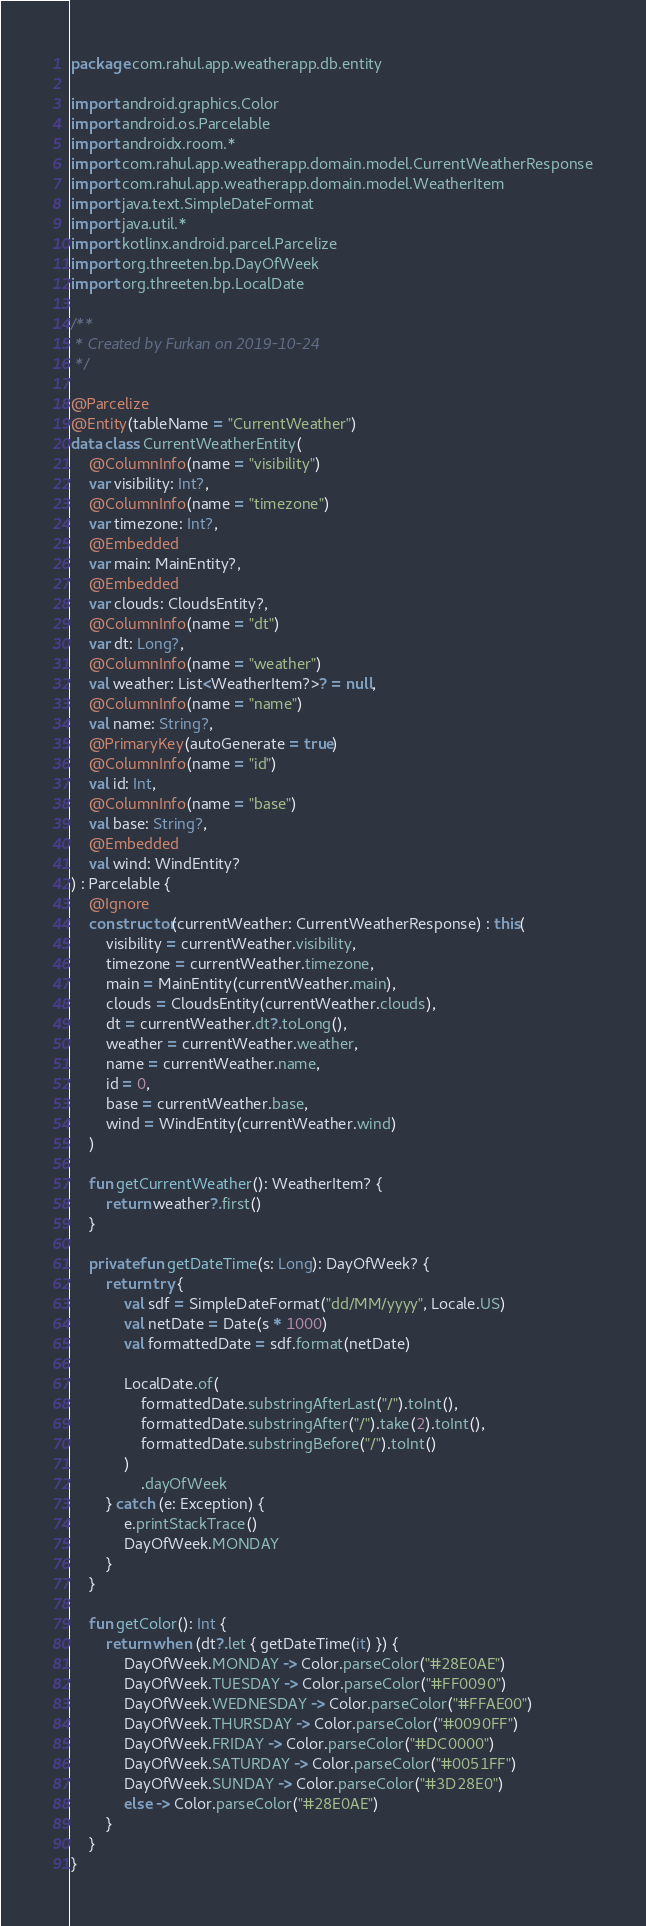Convert code to text. <code><loc_0><loc_0><loc_500><loc_500><_Kotlin_>package com.rahul.app.weatherapp.db.entity

import android.graphics.Color
import android.os.Parcelable
import androidx.room.*
import com.rahul.app.weatherapp.domain.model.CurrentWeatherResponse
import com.rahul.app.weatherapp.domain.model.WeatherItem
import java.text.SimpleDateFormat
import java.util.*
import kotlinx.android.parcel.Parcelize
import org.threeten.bp.DayOfWeek
import org.threeten.bp.LocalDate

/**
 * Created by Furkan on 2019-10-24
 */

@Parcelize
@Entity(tableName = "CurrentWeather")
data class CurrentWeatherEntity(
    @ColumnInfo(name = "visibility")
    var visibility: Int?,
    @ColumnInfo(name = "timezone")
    var timezone: Int?,
    @Embedded
    var main: MainEntity?,
    @Embedded
    var clouds: CloudsEntity?,
    @ColumnInfo(name = "dt")
    var dt: Long?,
    @ColumnInfo(name = "weather")
    val weather: List<WeatherItem?>? = null,
    @ColumnInfo(name = "name")
    val name: String?,
    @PrimaryKey(autoGenerate = true)
    @ColumnInfo(name = "id")
    val id: Int,
    @ColumnInfo(name = "base")
    val base: String?,
    @Embedded
    val wind: WindEntity?
) : Parcelable {
    @Ignore
    constructor(currentWeather: CurrentWeatherResponse) : this(
        visibility = currentWeather.visibility,
        timezone = currentWeather.timezone,
        main = MainEntity(currentWeather.main),
        clouds = CloudsEntity(currentWeather.clouds),
        dt = currentWeather.dt?.toLong(),
        weather = currentWeather.weather,
        name = currentWeather.name,
        id = 0,
        base = currentWeather.base,
        wind = WindEntity(currentWeather.wind)
    )

    fun getCurrentWeather(): WeatherItem? {
        return weather?.first()
    }

    private fun getDateTime(s: Long): DayOfWeek? {
        return try {
            val sdf = SimpleDateFormat("dd/MM/yyyy", Locale.US)
            val netDate = Date(s * 1000)
            val formattedDate = sdf.format(netDate)

            LocalDate.of(
                formattedDate.substringAfterLast("/").toInt(),
                formattedDate.substringAfter("/").take(2).toInt(),
                formattedDate.substringBefore("/").toInt()
            )
                .dayOfWeek
        } catch (e: Exception) {
            e.printStackTrace()
            DayOfWeek.MONDAY
        }
    }

    fun getColor(): Int {
        return when (dt?.let { getDateTime(it) }) {
            DayOfWeek.MONDAY -> Color.parseColor("#28E0AE")
            DayOfWeek.TUESDAY -> Color.parseColor("#FF0090")
            DayOfWeek.WEDNESDAY -> Color.parseColor("#FFAE00")
            DayOfWeek.THURSDAY -> Color.parseColor("#0090FF")
            DayOfWeek.FRIDAY -> Color.parseColor("#DC0000")
            DayOfWeek.SATURDAY -> Color.parseColor("#0051FF")
            DayOfWeek.SUNDAY -> Color.parseColor("#3D28E0")
            else -> Color.parseColor("#28E0AE")
        }
    }
}
</code> 